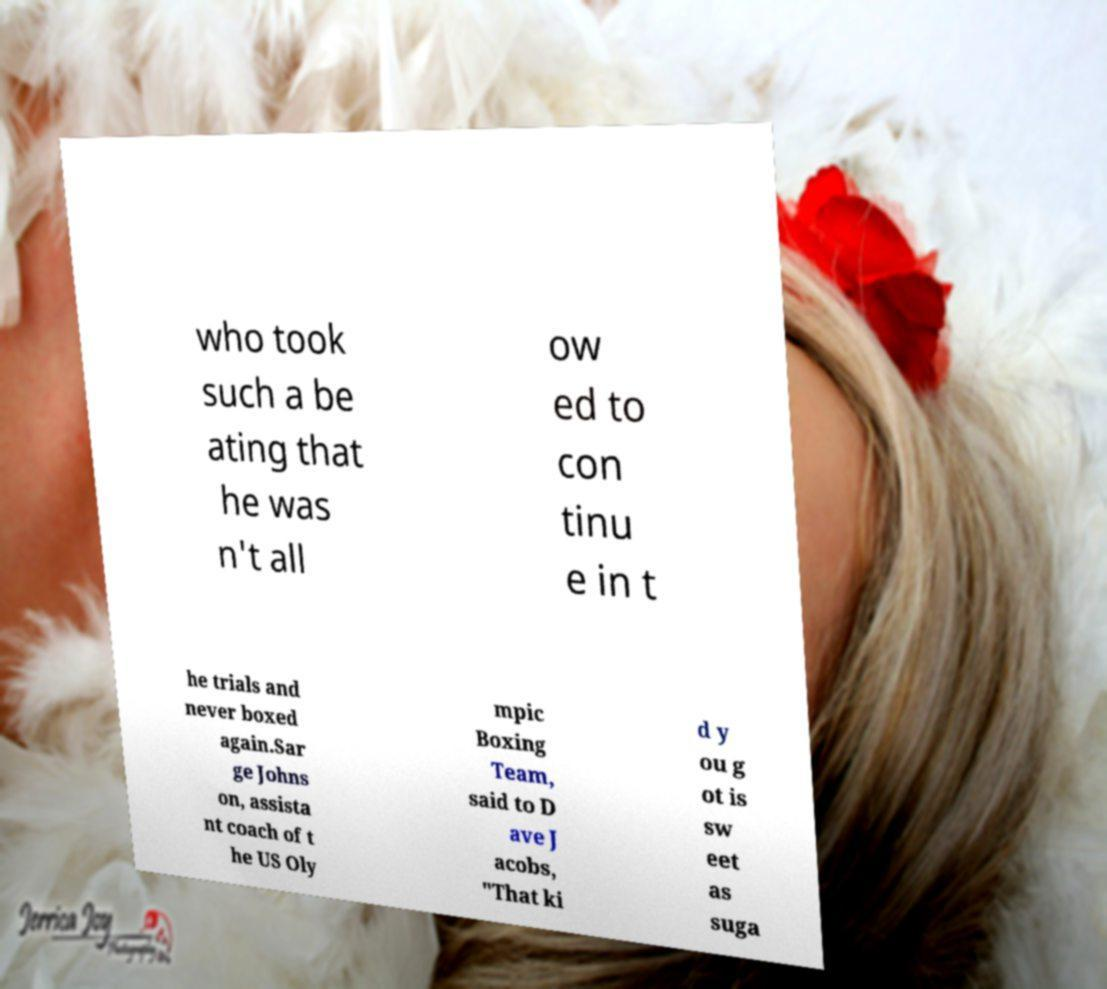Could you assist in decoding the text presented in this image and type it out clearly? who took such a be ating that he was n't all ow ed to con tinu e in t he trials and never boxed again.Sar ge Johns on, assista nt coach of t he US Oly mpic Boxing Team, said to D ave J acobs, "That ki d y ou g ot is sw eet as suga 